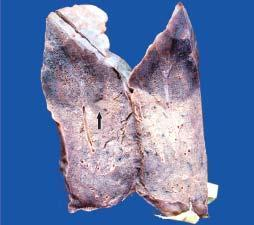what is the color of the firm areas with base on the pleura?
Answer the question using a single word or phrase. Dark tan 